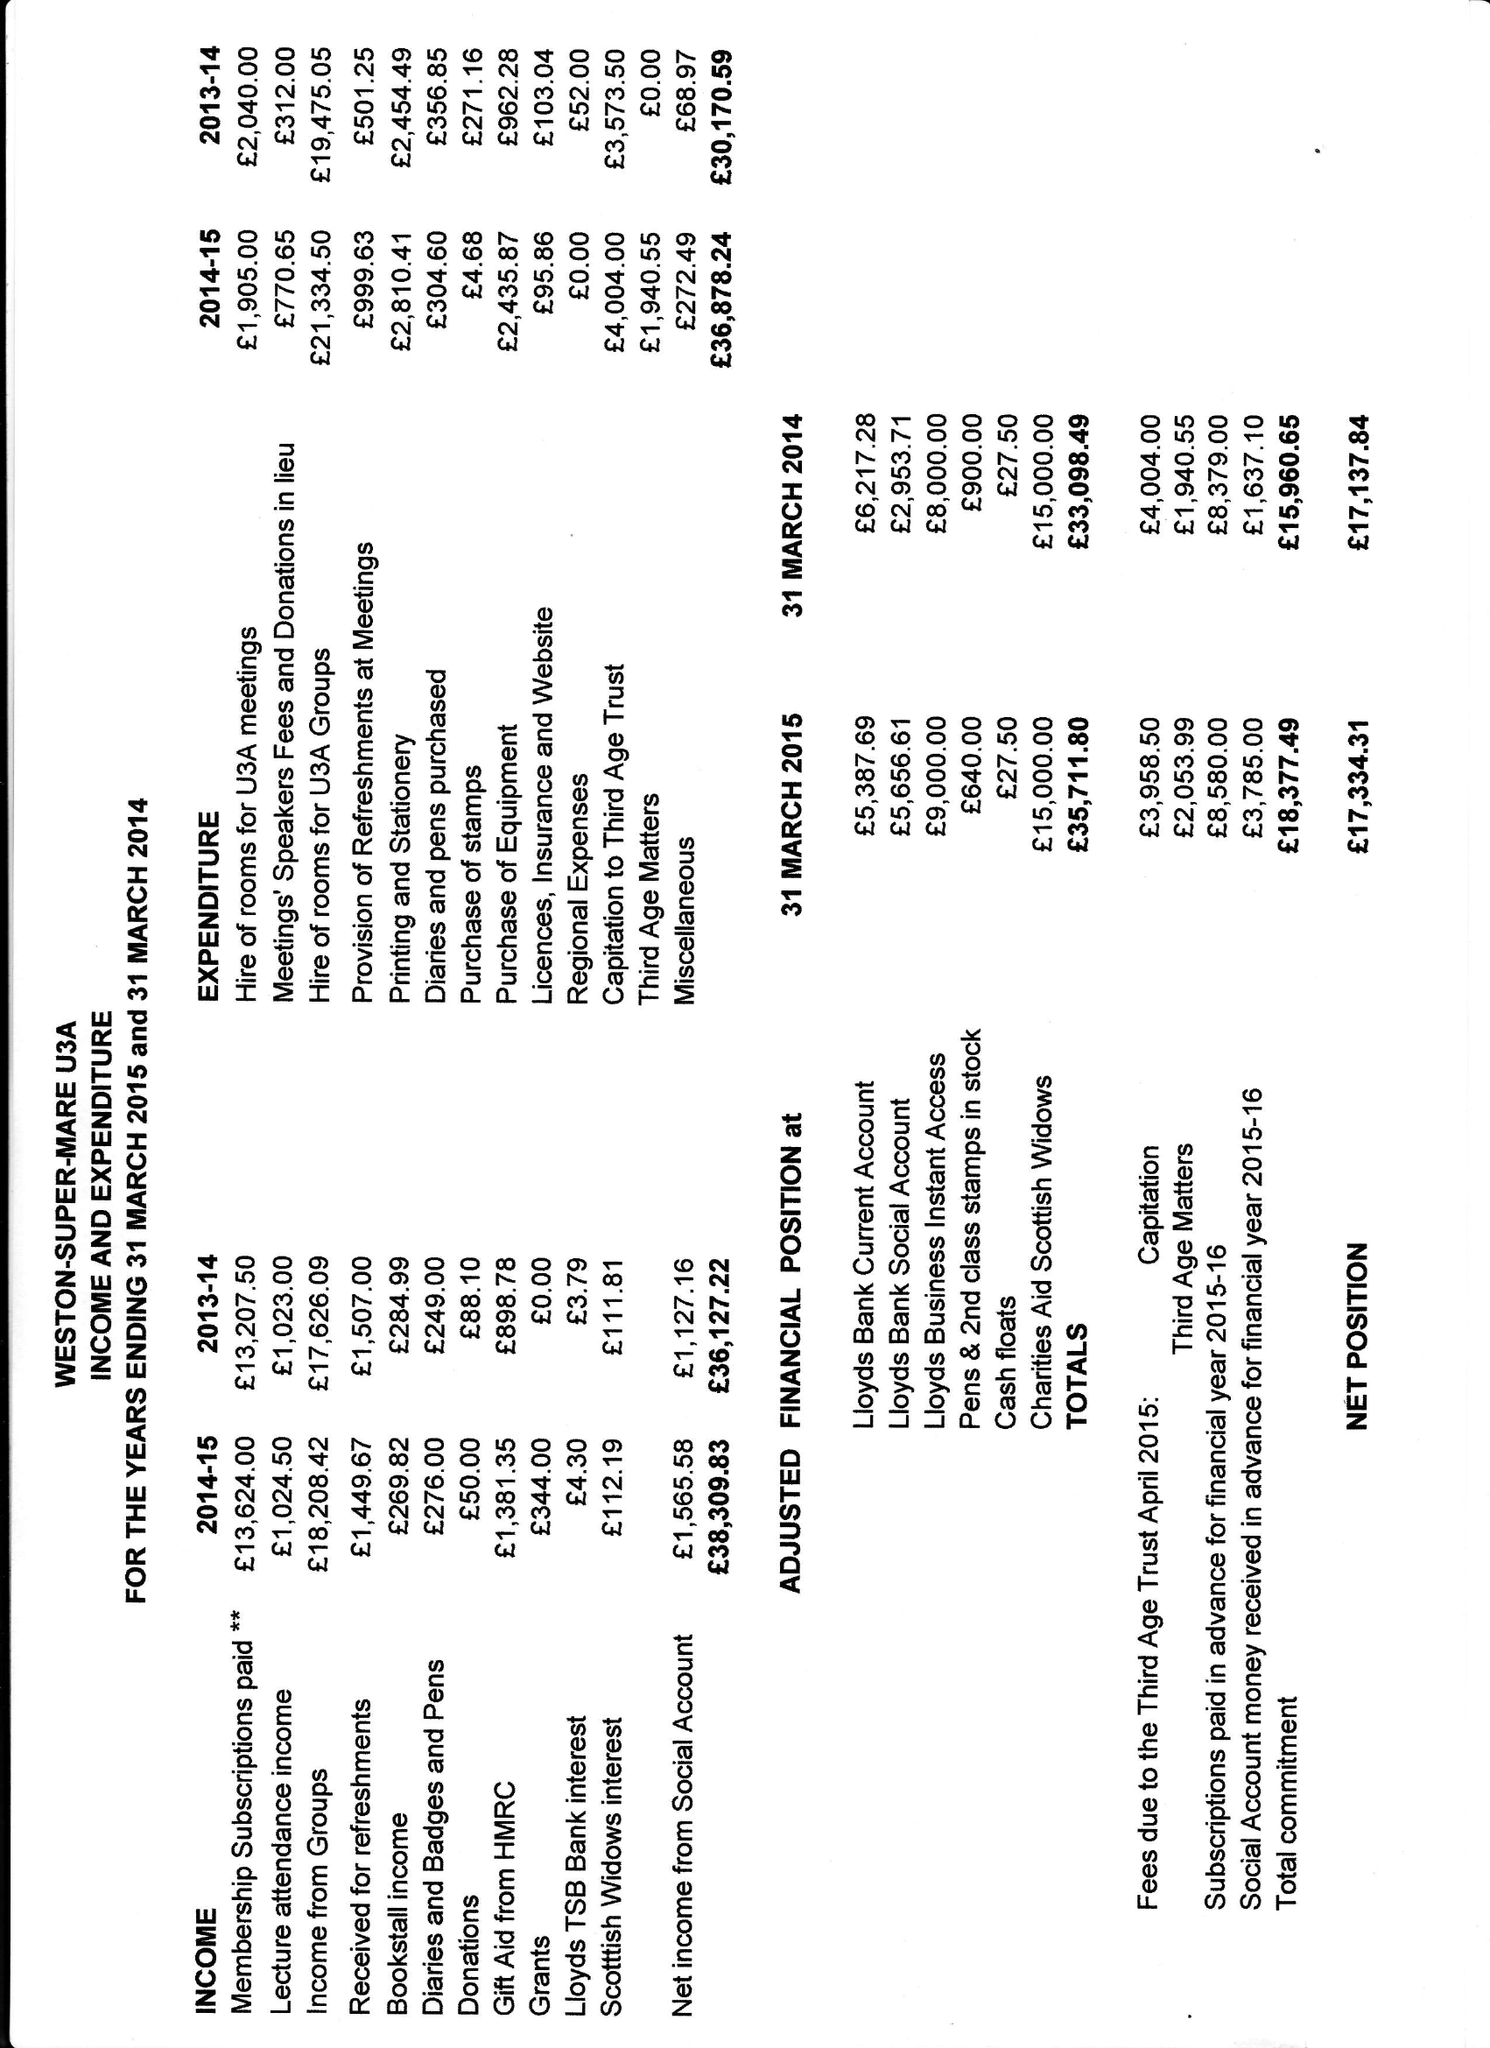What is the value for the address__postcode?
Answer the question using a single word or phrase. None 